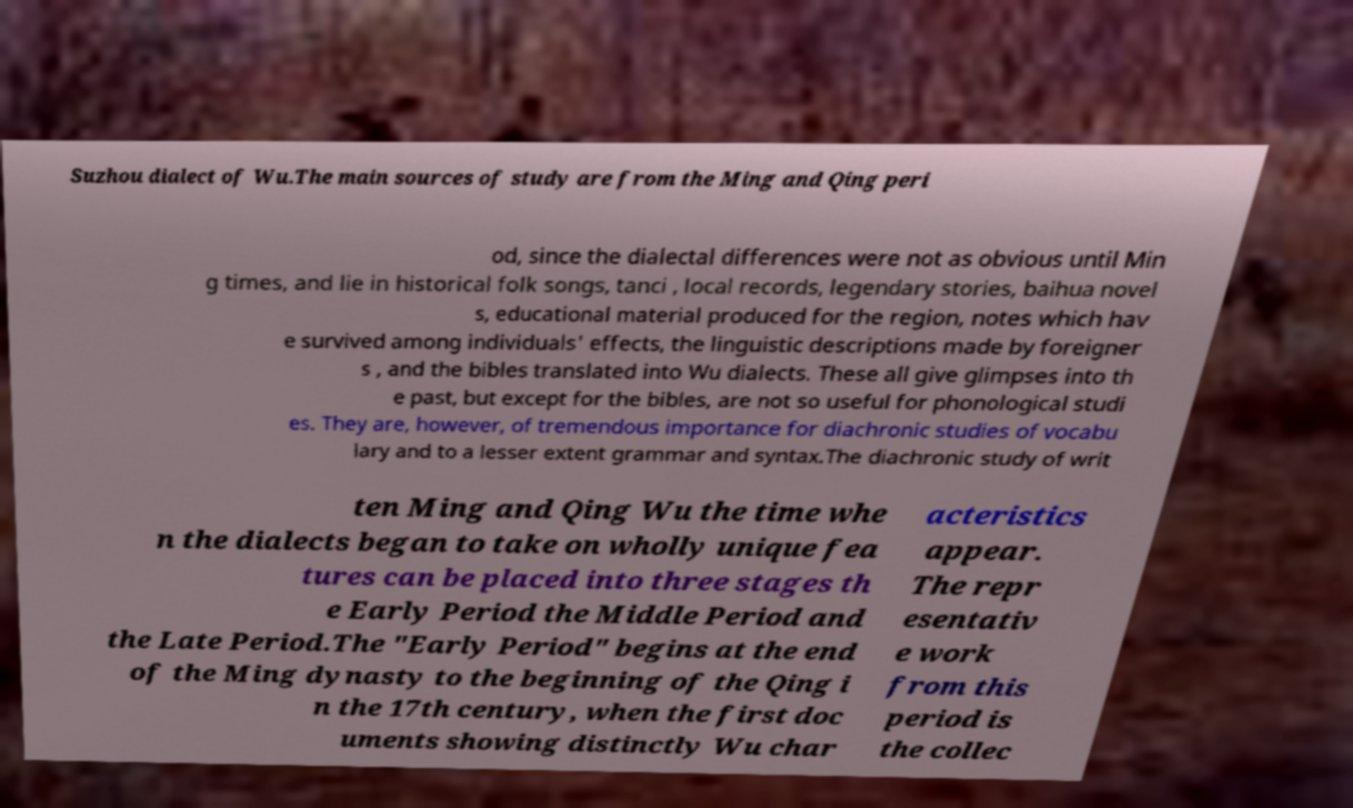I need the written content from this picture converted into text. Can you do that? Suzhou dialect of Wu.The main sources of study are from the Ming and Qing peri od, since the dialectal differences were not as obvious until Min g times, and lie in historical folk songs, tanci , local records, legendary stories, baihua novel s, educational material produced for the region, notes which hav e survived among individuals' effects, the linguistic descriptions made by foreigner s , and the bibles translated into Wu dialects. These all give glimpses into th e past, but except for the bibles, are not so useful for phonological studi es. They are, however, of tremendous importance for diachronic studies of vocabu lary and to a lesser extent grammar and syntax.The diachronic study of writ ten Ming and Qing Wu the time whe n the dialects began to take on wholly unique fea tures can be placed into three stages th e Early Period the Middle Period and the Late Period.The "Early Period" begins at the end of the Ming dynasty to the beginning of the Qing i n the 17th century, when the first doc uments showing distinctly Wu char acteristics appear. The repr esentativ e work from this period is the collec 